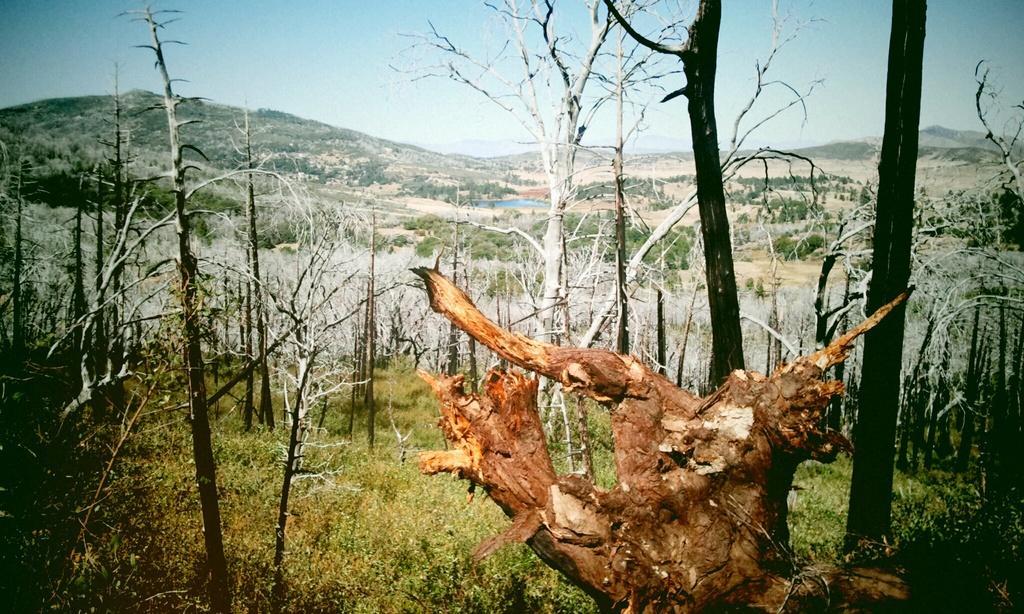Can you describe this image briefly? In the foreground of the picture there is a wooden log. In this picture there are trees, plants and grass. In the background there are trees, hills, water body and other objects. 